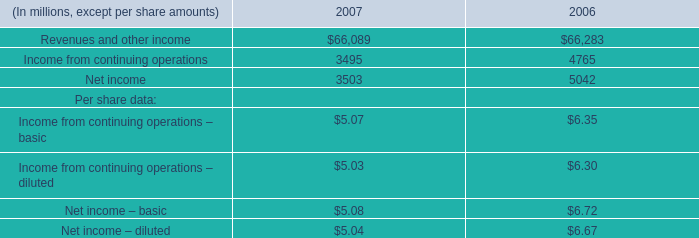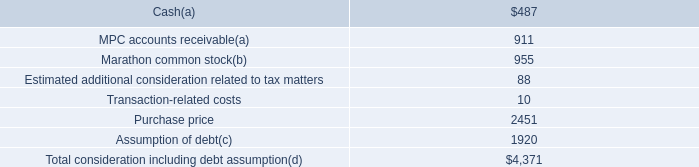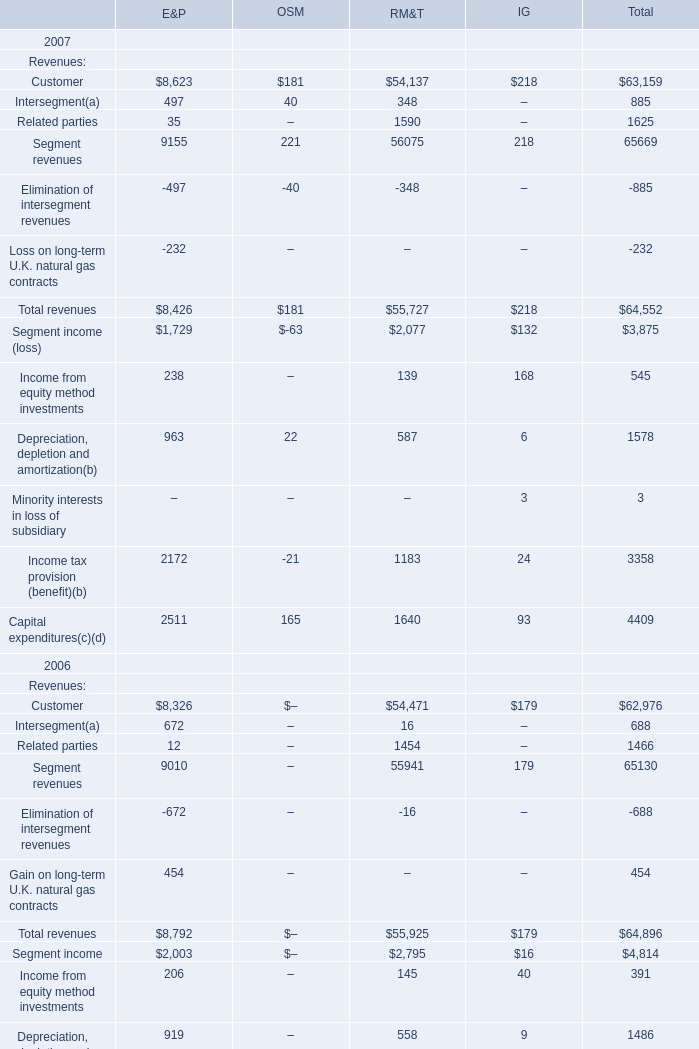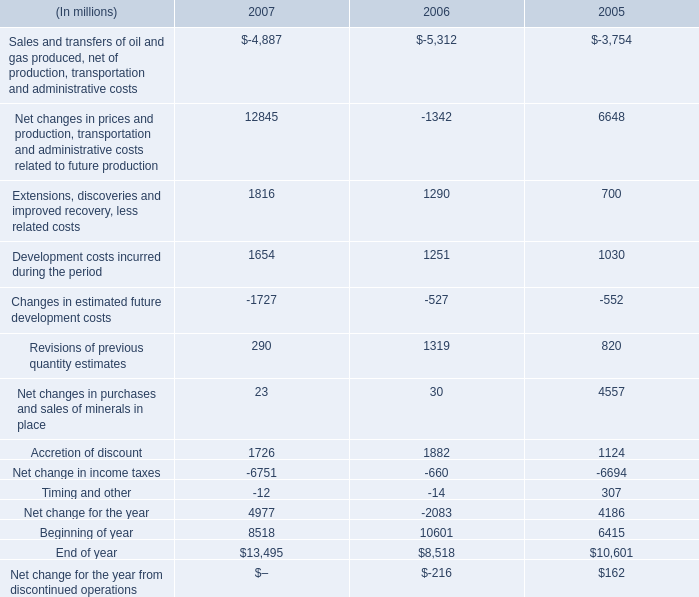if current development costs increased in 2008 as much as in 2007 , what would the 2008 total be , in millions? 
Computations: ((1654 - 1251) + 1654)
Answer: 2057.0. 